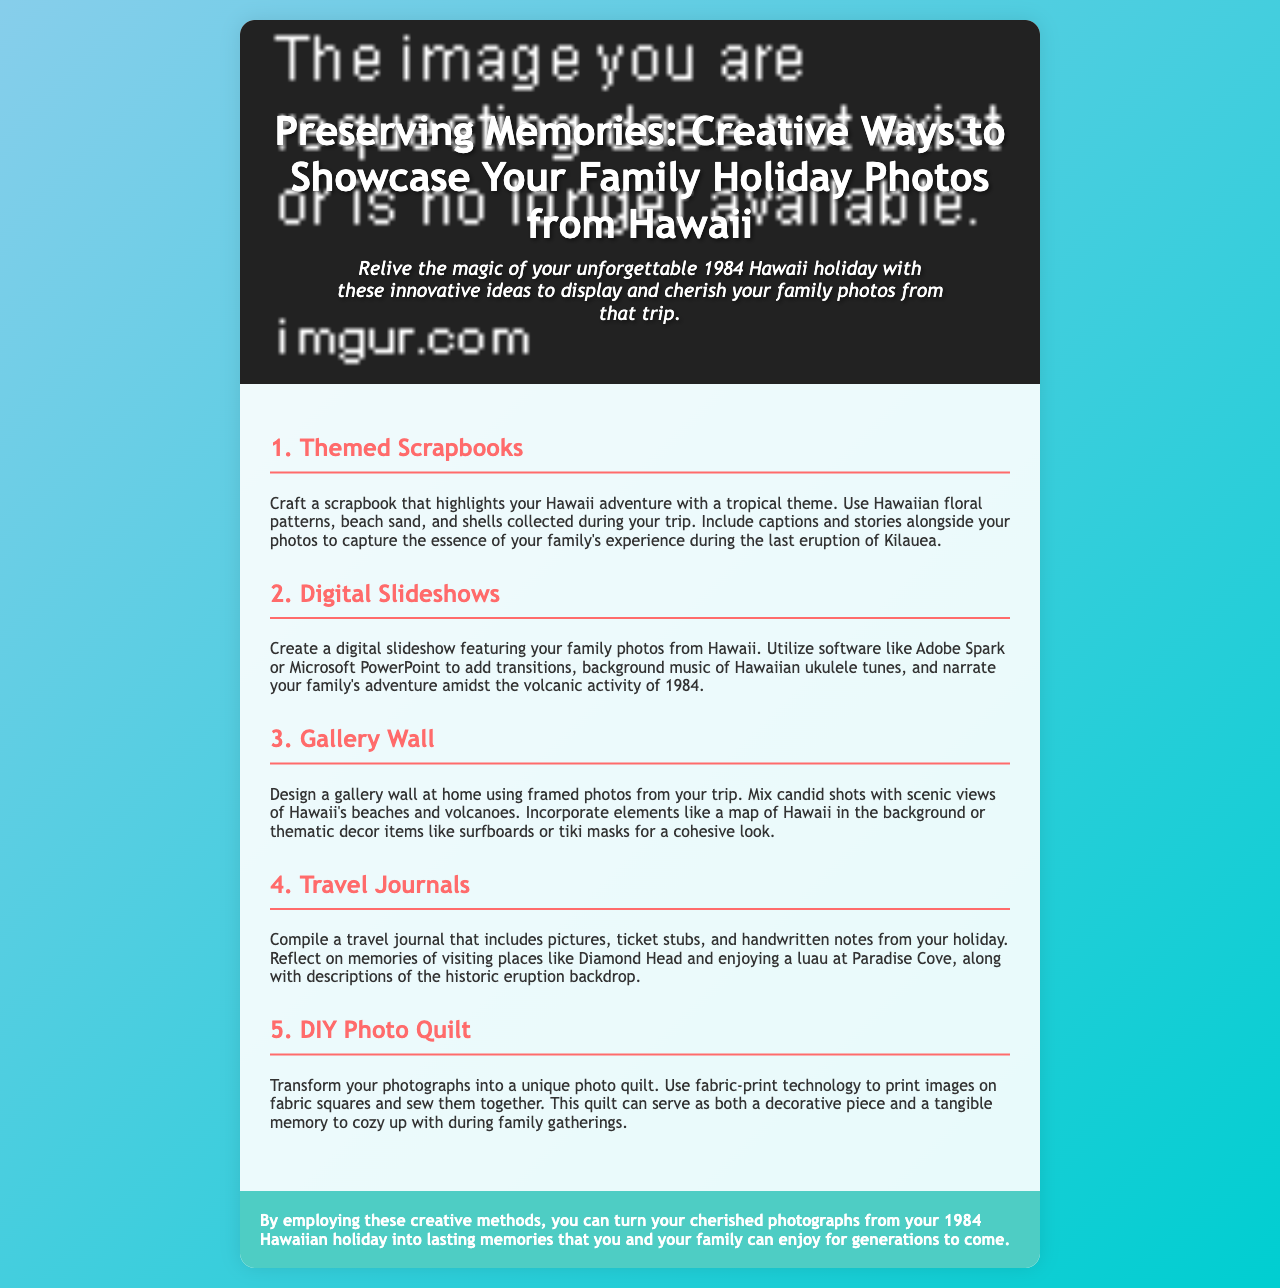What is the title of the brochure? The title is provided in the header section of the document, which introduces the main theme of the brochure.
Answer: Preserving Memories: Creative Ways to Showcase Your Family Holiday Photos from Hawaii In which year did the family holiday occur? The introductory sentence of the brochure specifically mentions the year of the family holiday.
Answer: 1984 What is the first method suggested for showcasing photos? The document lists several methods in separate sections, starting with the first one which emphasizes a creative approach to scrapbooking.
Answer: Themed Scrapbooks What unique element is suggested to include in a scrapbook? The scrapbooking section mentions specific items that could enhance the creative display of memories.
Answer: Hawaiian floral patterns What technology is recommended for creating digital slideshows? The document specifies software options that can be utilized to create engaging digital presentations of family photos.
Answer: Adobe Spark or Microsoft PowerPoint How can a travel journal enhance memories? The travel journal section highlights different components that collectively serve to evoke recollections of the trip.
Answer: Pictures, ticket stubs, and handwritten notes What material is suggested for a DIY photo quilt? This method involves a way to incorporate photographs into a specific type of textile, making it a tactile memory.
Answer: Fabric squares What is the concluding message of the brochure? The conclusion emphasizes the importance and longevity of the methods suggested for preserving family memories.
Answer: Lasting memories 